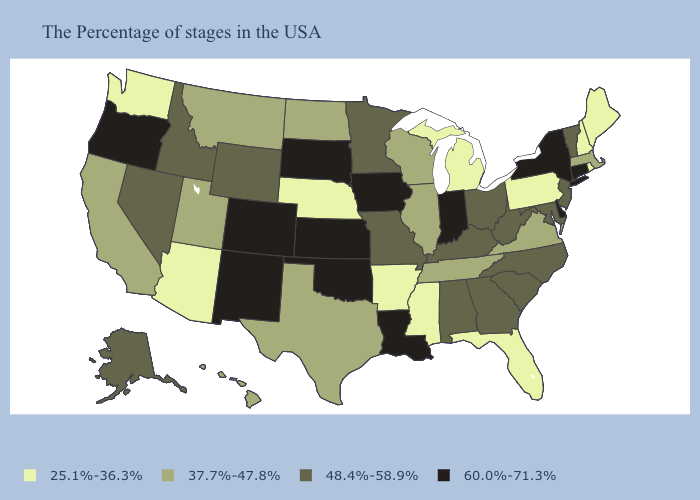Does Michigan have the same value as Nevada?
Quick response, please. No. Name the states that have a value in the range 60.0%-71.3%?
Give a very brief answer. Connecticut, New York, Delaware, Indiana, Louisiana, Iowa, Kansas, Oklahoma, South Dakota, Colorado, New Mexico, Oregon. Among the states that border New Jersey , which have the lowest value?
Keep it brief. Pennsylvania. What is the value of Tennessee?
Answer briefly. 37.7%-47.8%. Among the states that border Connecticut , which have the highest value?
Write a very short answer. New York. What is the highest value in states that border New Hampshire?
Give a very brief answer. 48.4%-58.9%. What is the value of West Virginia?
Be succinct. 48.4%-58.9%. What is the value of Pennsylvania?
Keep it brief. 25.1%-36.3%. Name the states that have a value in the range 37.7%-47.8%?
Short answer required. Massachusetts, Virginia, Tennessee, Wisconsin, Illinois, Texas, North Dakota, Utah, Montana, California, Hawaii. Does Georgia have a lower value than Wisconsin?
Concise answer only. No. Name the states that have a value in the range 60.0%-71.3%?
Give a very brief answer. Connecticut, New York, Delaware, Indiana, Louisiana, Iowa, Kansas, Oklahoma, South Dakota, Colorado, New Mexico, Oregon. Does Indiana have the highest value in the USA?
Be succinct. Yes. Among the states that border Louisiana , which have the highest value?
Short answer required. Texas. What is the highest value in the USA?
Concise answer only. 60.0%-71.3%. Does the map have missing data?
Give a very brief answer. No. 